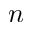<formula> <loc_0><loc_0><loc_500><loc_500>n</formula> 